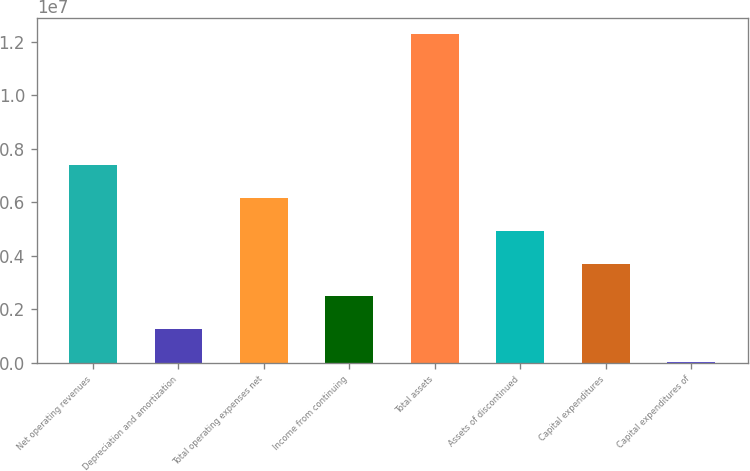<chart> <loc_0><loc_0><loc_500><loc_500><bar_chart><fcel>Net operating revenues<fcel>Depreciation and amortization<fcel>Total operating expenses net<fcel>Income from continuing<fcel>Total assets<fcel>Assets of discontinued<fcel>Capital expenditures<fcel>Capital expenditures of<nl><fcel>7.38517e+06<fcel>1.25313e+06<fcel>6.15876e+06<fcel>2.47954e+06<fcel>1.22908e+07<fcel>4.93235e+06<fcel>3.70595e+06<fcel>26725<nl></chart> 